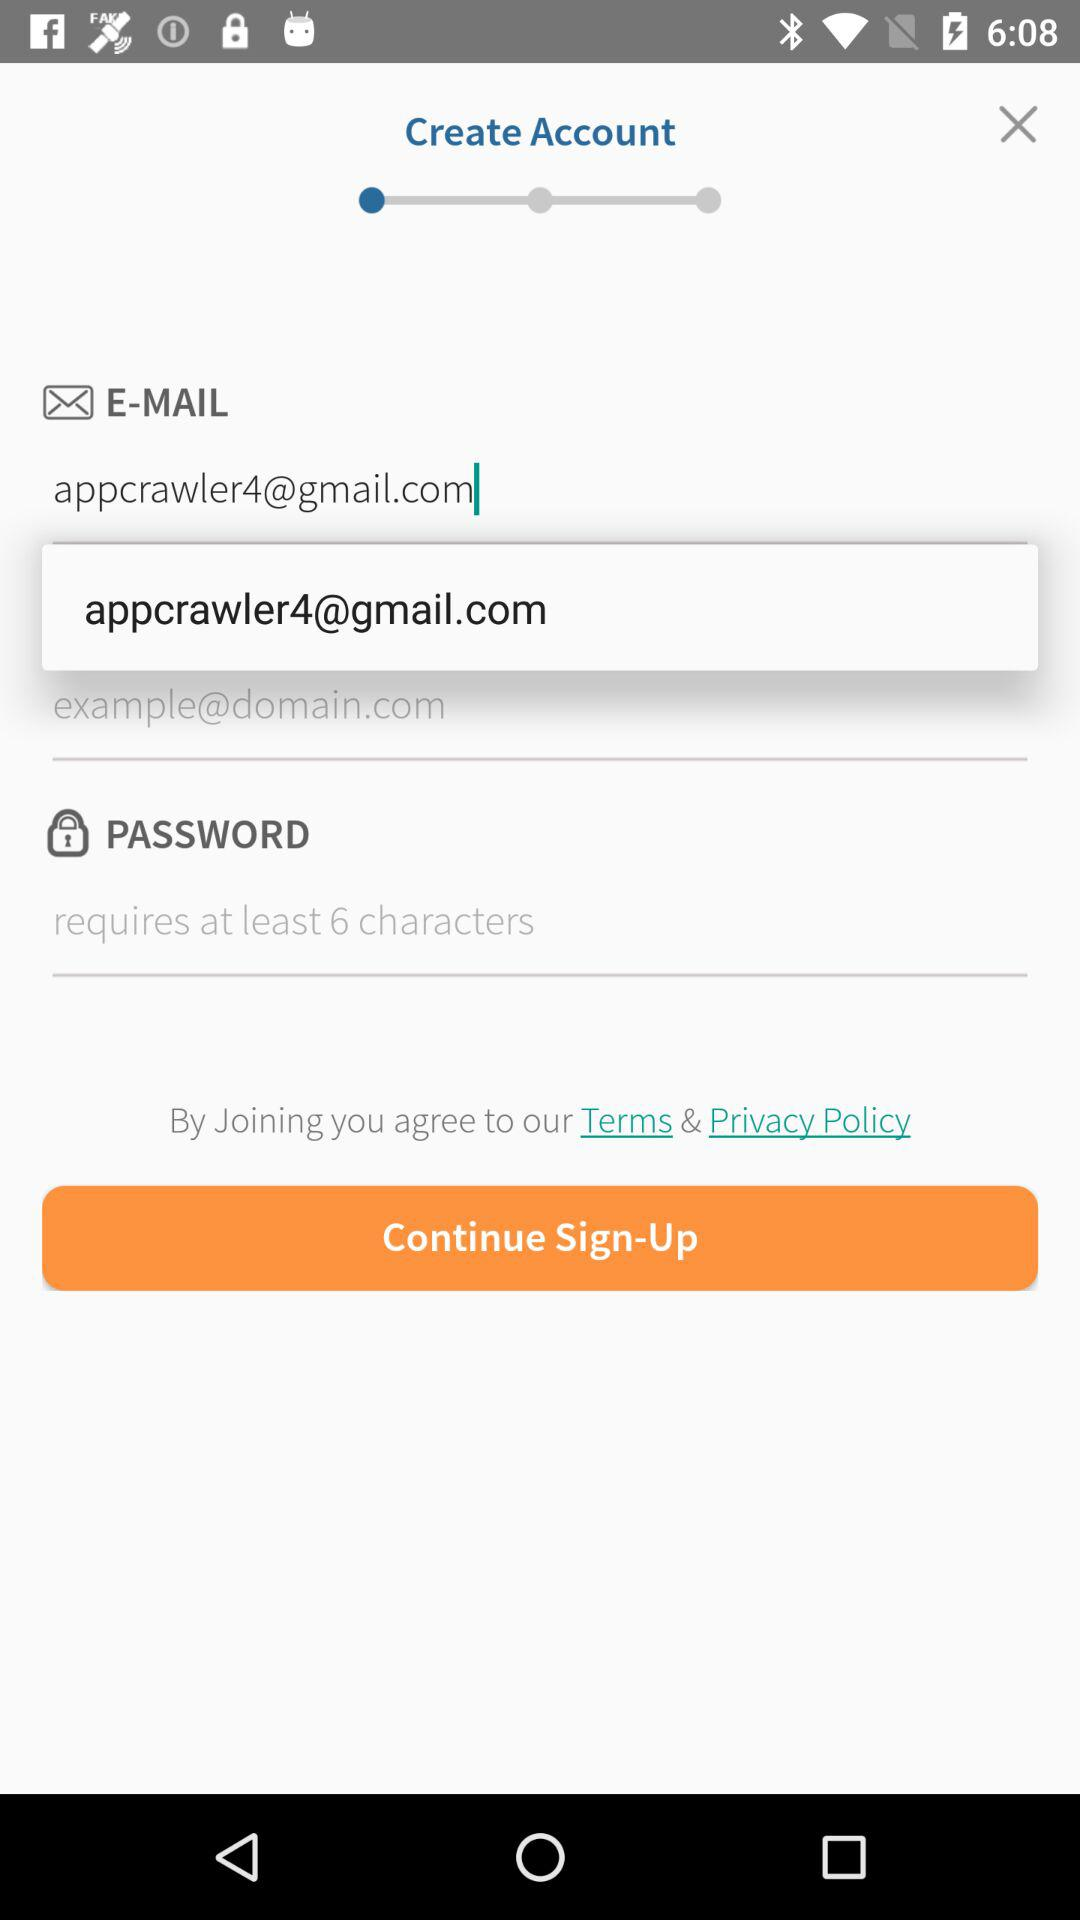How many characters are required for a password? There are at least 6 characters required. 